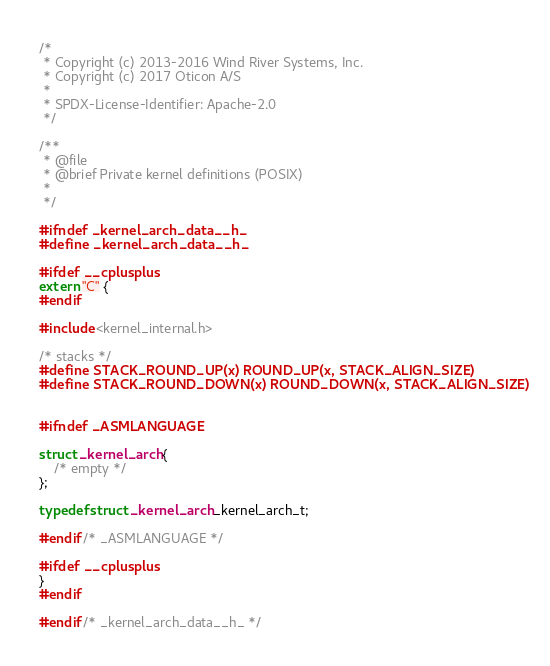<code> <loc_0><loc_0><loc_500><loc_500><_C_>/*
 * Copyright (c) 2013-2016 Wind River Systems, Inc.
 * Copyright (c) 2017 Oticon A/S
 *
 * SPDX-License-Identifier: Apache-2.0
 */

/**
 * @file
 * @brief Private kernel definitions (POSIX)
 *
 */

#ifndef _kernel_arch_data__h_
#define _kernel_arch_data__h_

#ifdef __cplusplus
extern "C" {
#endif

#include <kernel_internal.h>

/* stacks */
#define STACK_ROUND_UP(x) ROUND_UP(x, STACK_ALIGN_SIZE)
#define STACK_ROUND_DOWN(x) ROUND_DOWN(x, STACK_ALIGN_SIZE)


#ifndef _ASMLANGUAGE

struct _kernel_arch {
	/* empty */
};

typedef struct _kernel_arch _kernel_arch_t;

#endif /* _ASMLANGUAGE */

#ifdef __cplusplus
}
#endif

#endif /* _kernel_arch_data__h_ */
</code> 